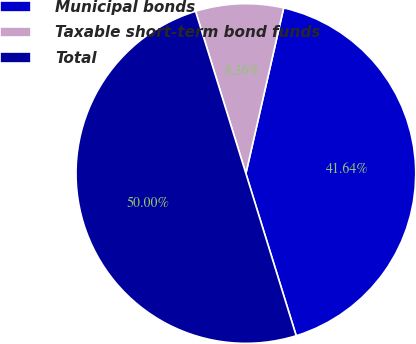Convert chart to OTSL. <chart><loc_0><loc_0><loc_500><loc_500><pie_chart><fcel>Municipal bonds<fcel>Taxable short-term bond funds<fcel>Total<nl><fcel>41.64%<fcel>8.36%<fcel>50.0%<nl></chart> 